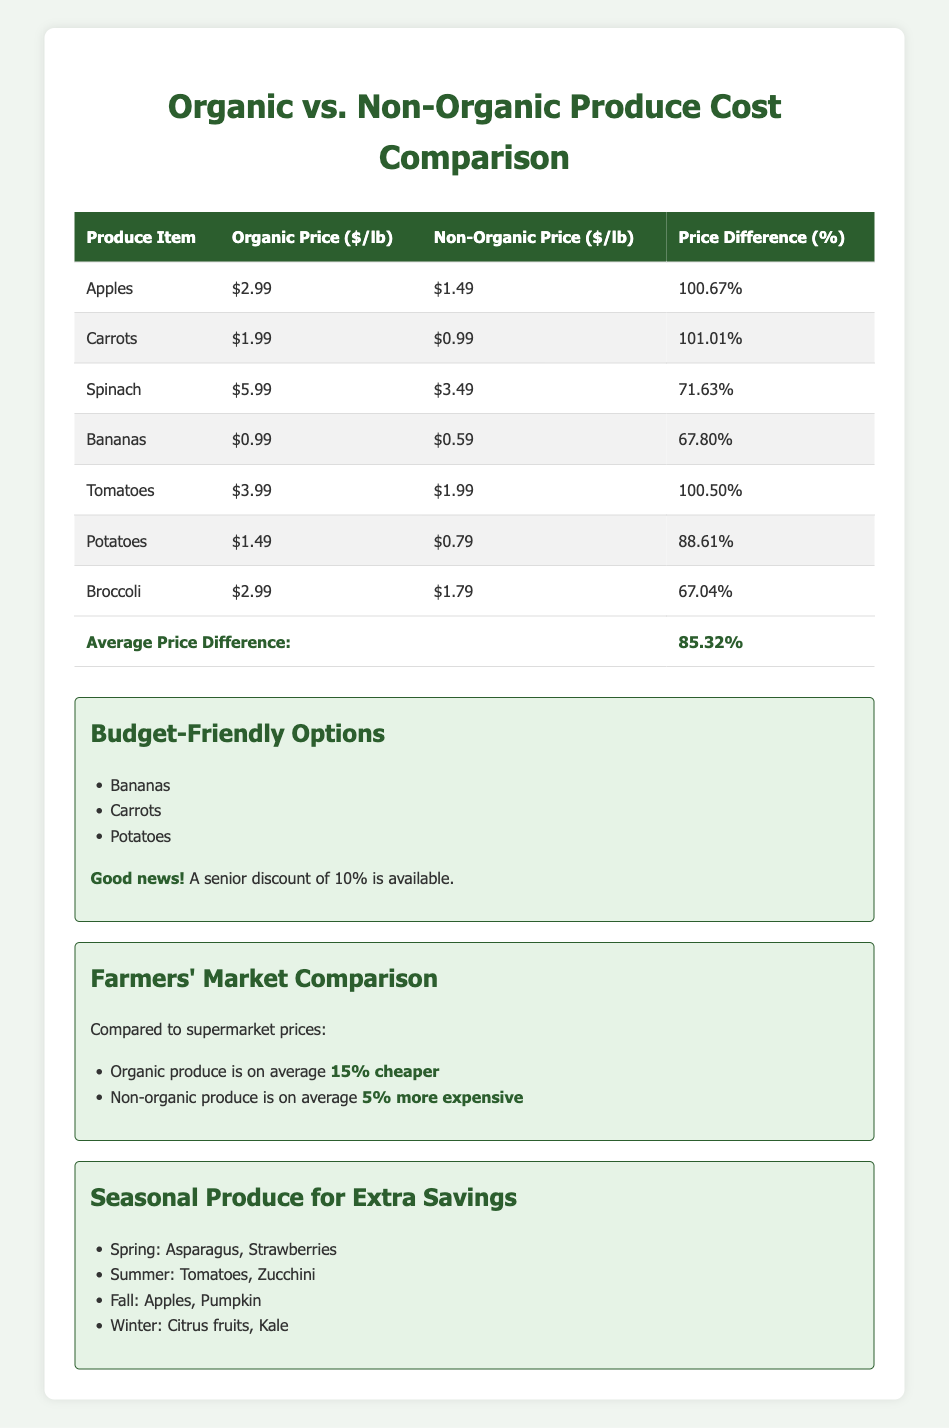What is the price difference percentage for organic apples compared to non-organic apples? From the table, the price difference percentage for organic apples is listed as 100.67%. This is a direct retrieval from the relevant row in the table.
Answer: 100.67% Which produce item has the highest organic price per pound? Looking through the table, the organic price per pound for spinach is $5.99, which is the highest among all listed items. This is assessed by comparing the organic prices directly.
Answer: Spinach What is the average organic price per pound of the listed produce items? To find the average, sum the organic prices: 2.99 + 1.99 + 5.99 + 0.99 + 3.99 + 1.49 + 2.99 = 19.42. Then divide by 7 (the number of items): 19.42 / 7 = 2.78.
Answer: 2.78 Is there a senior discount available for purchases? The table indicates that a senior discount is available, with a discount percentage of 10%. This is confirmed directly from the specific information provided in the table.
Answer: Yes Which is cheaper on average, organic or non-organic produce? The table states that organic produce is, on average, 15% cheaper at farmers' markets while non-organic is 5% more expensive. Since organic is cheaper, the conclusion comes from comparing these two percentages.
Answer: Organic produce Among the budget-friendly options, which item has the lowest organic price per pound? The budget-friendly options listed are bananas, carrots, and potatoes. Checking their organic prices, bananas at $0.99 are the lowest compared to carrots at $1.99 and potatoes at $1.49. Thus, a comparison of fluid price points leads to this answer.
Answer: Bananas What is the total price difference percentage for all produce items combined? The average price difference percentage across all items is provided as 85.32%. This is an overall figure that summarizes the differences without needing individual calculations.
Answer: 85.32% Which seasonal produce items can help save money during the fall? The seasonal produce listed for fall includes apples and pumpkin. This is noted directly from the seasonal produce section in the table.
Answer: Apples, Pumpkin How much more expensive are organic carrots compared to non-organic carrots in percentage? The price difference for organic carrots is listed as 101.01%, indicating how much more organic carrots are compared to non-organic. This can be found directly in the table.
Answer: 101.01% 